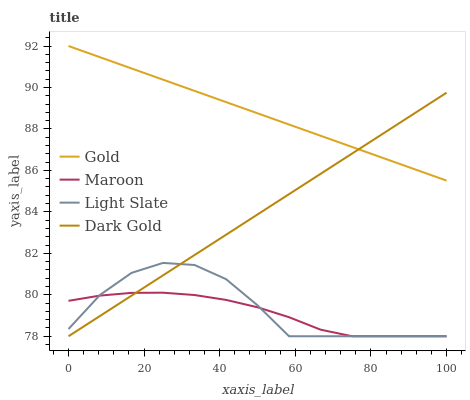Does Maroon have the minimum area under the curve?
Answer yes or no. Yes. Does Gold have the maximum area under the curve?
Answer yes or no. Yes. Does Gold have the minimum area under the curve?
Answer yes or no. No. Does Maroon have the maximum area under the curve?
Answer yes or no. No. Is Dark Gold the smoothest?
Answer yes or no. Yes. Is Light Slate the roughest?
Answer yes or no. Yes. Is Maroon the smoothest?
Answer yes or no. No. Is Maroon the roughest?
Answer yes or no. No. Does Light Slate have the lowest value?
Answer yes or no. Yes. Does Gold have the lowest value?
Answer yes or no. No. Does Gold have the highest value?
Answer yes or no. Yes. Does Maroon have the highest value?
Answer yes or no. No. Is Light Slate less than Gold?
Answer yes or no. Yes. Is Gold greater than Maroon?
Answer yes or no. Yes. Does Gold intersect Dark Gold?
Answer yes or no. Yes. Is Gold less than Dark Gold?
Answer yes or no. No. Is Gold greater than Dark Gold?
Answer yes or no. No. Does Light Slate intersect Gold?
Answer yes or no. No. 